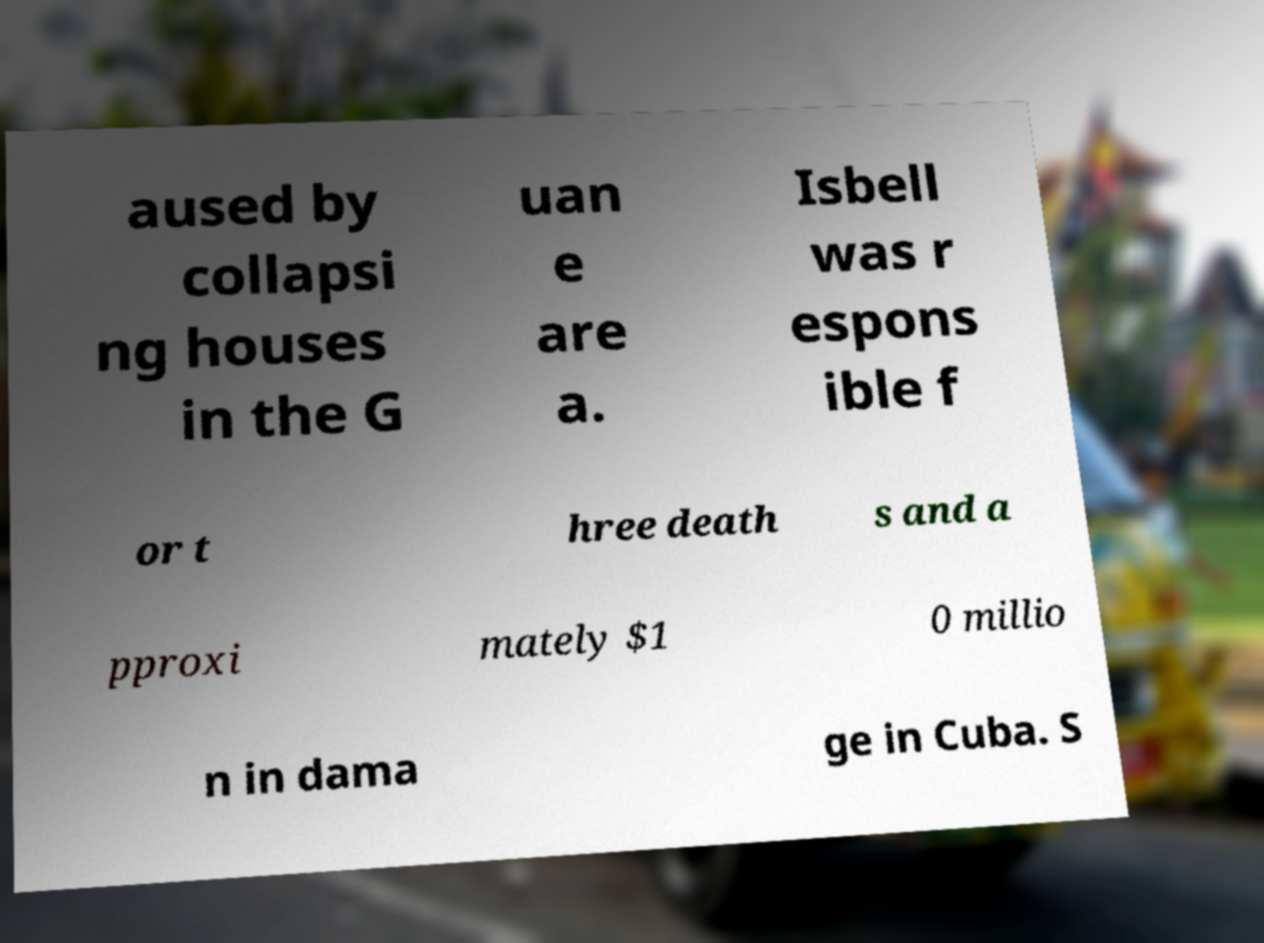I need the written content from this picture converted into text. Can you do that? aused by collapsi ng houses in the G uan e are a. Isbell was r espons ible f or t hree death s and a pproxi mately $1 0 millio n in dama ge in Cuba. S 